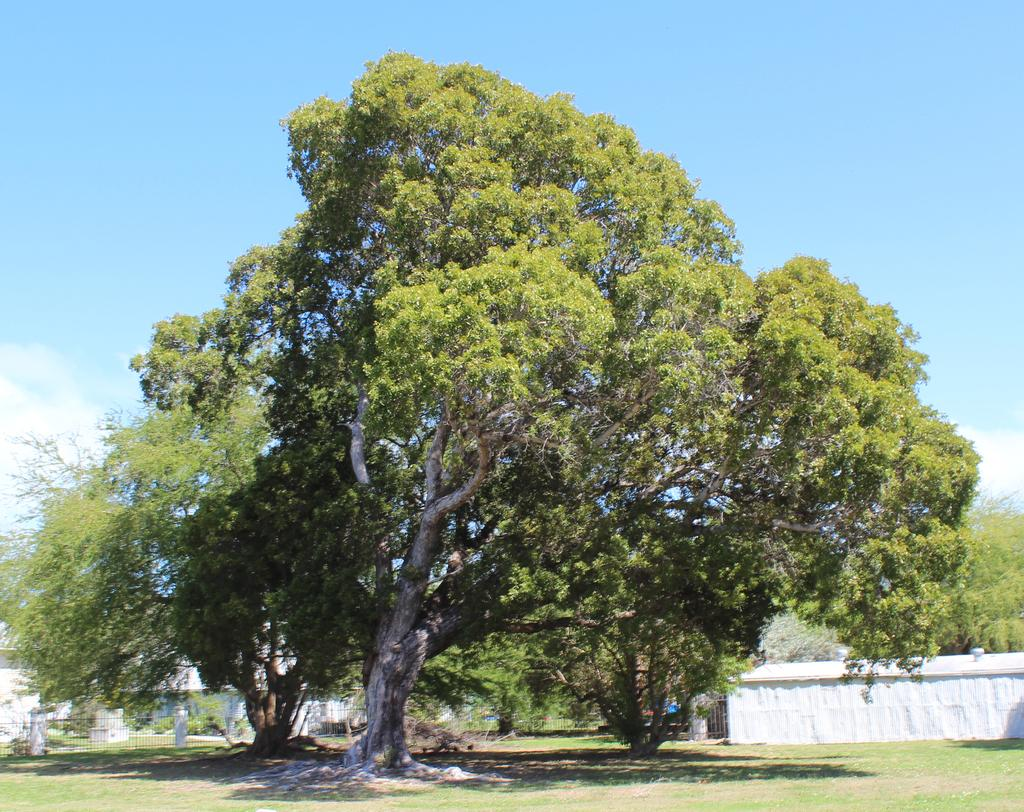What is the main subject in the middle of the image? There is a tree in the middle of the image. What structure is located on the right side of the image? There is a wall on the right side of the image. What is visible at the top of the image? The sky is visible at the top of the image. What can be seen in the background on the left side of the image? There is a fence in the background on the left side of the image. What type of punishment is being administered to the tree in the image? There is no punishment being administered to the tree in the image; it is a stationary object in the scene. What kind of bait is attached to the tree in the image? There is no bait present in the image; it features a tree, a wall, the sky, and a fence. 